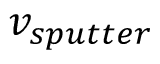<formula> <loc_0><loc_0><loc_500><loc_500>v _ { s p u t t e r }</formula> 